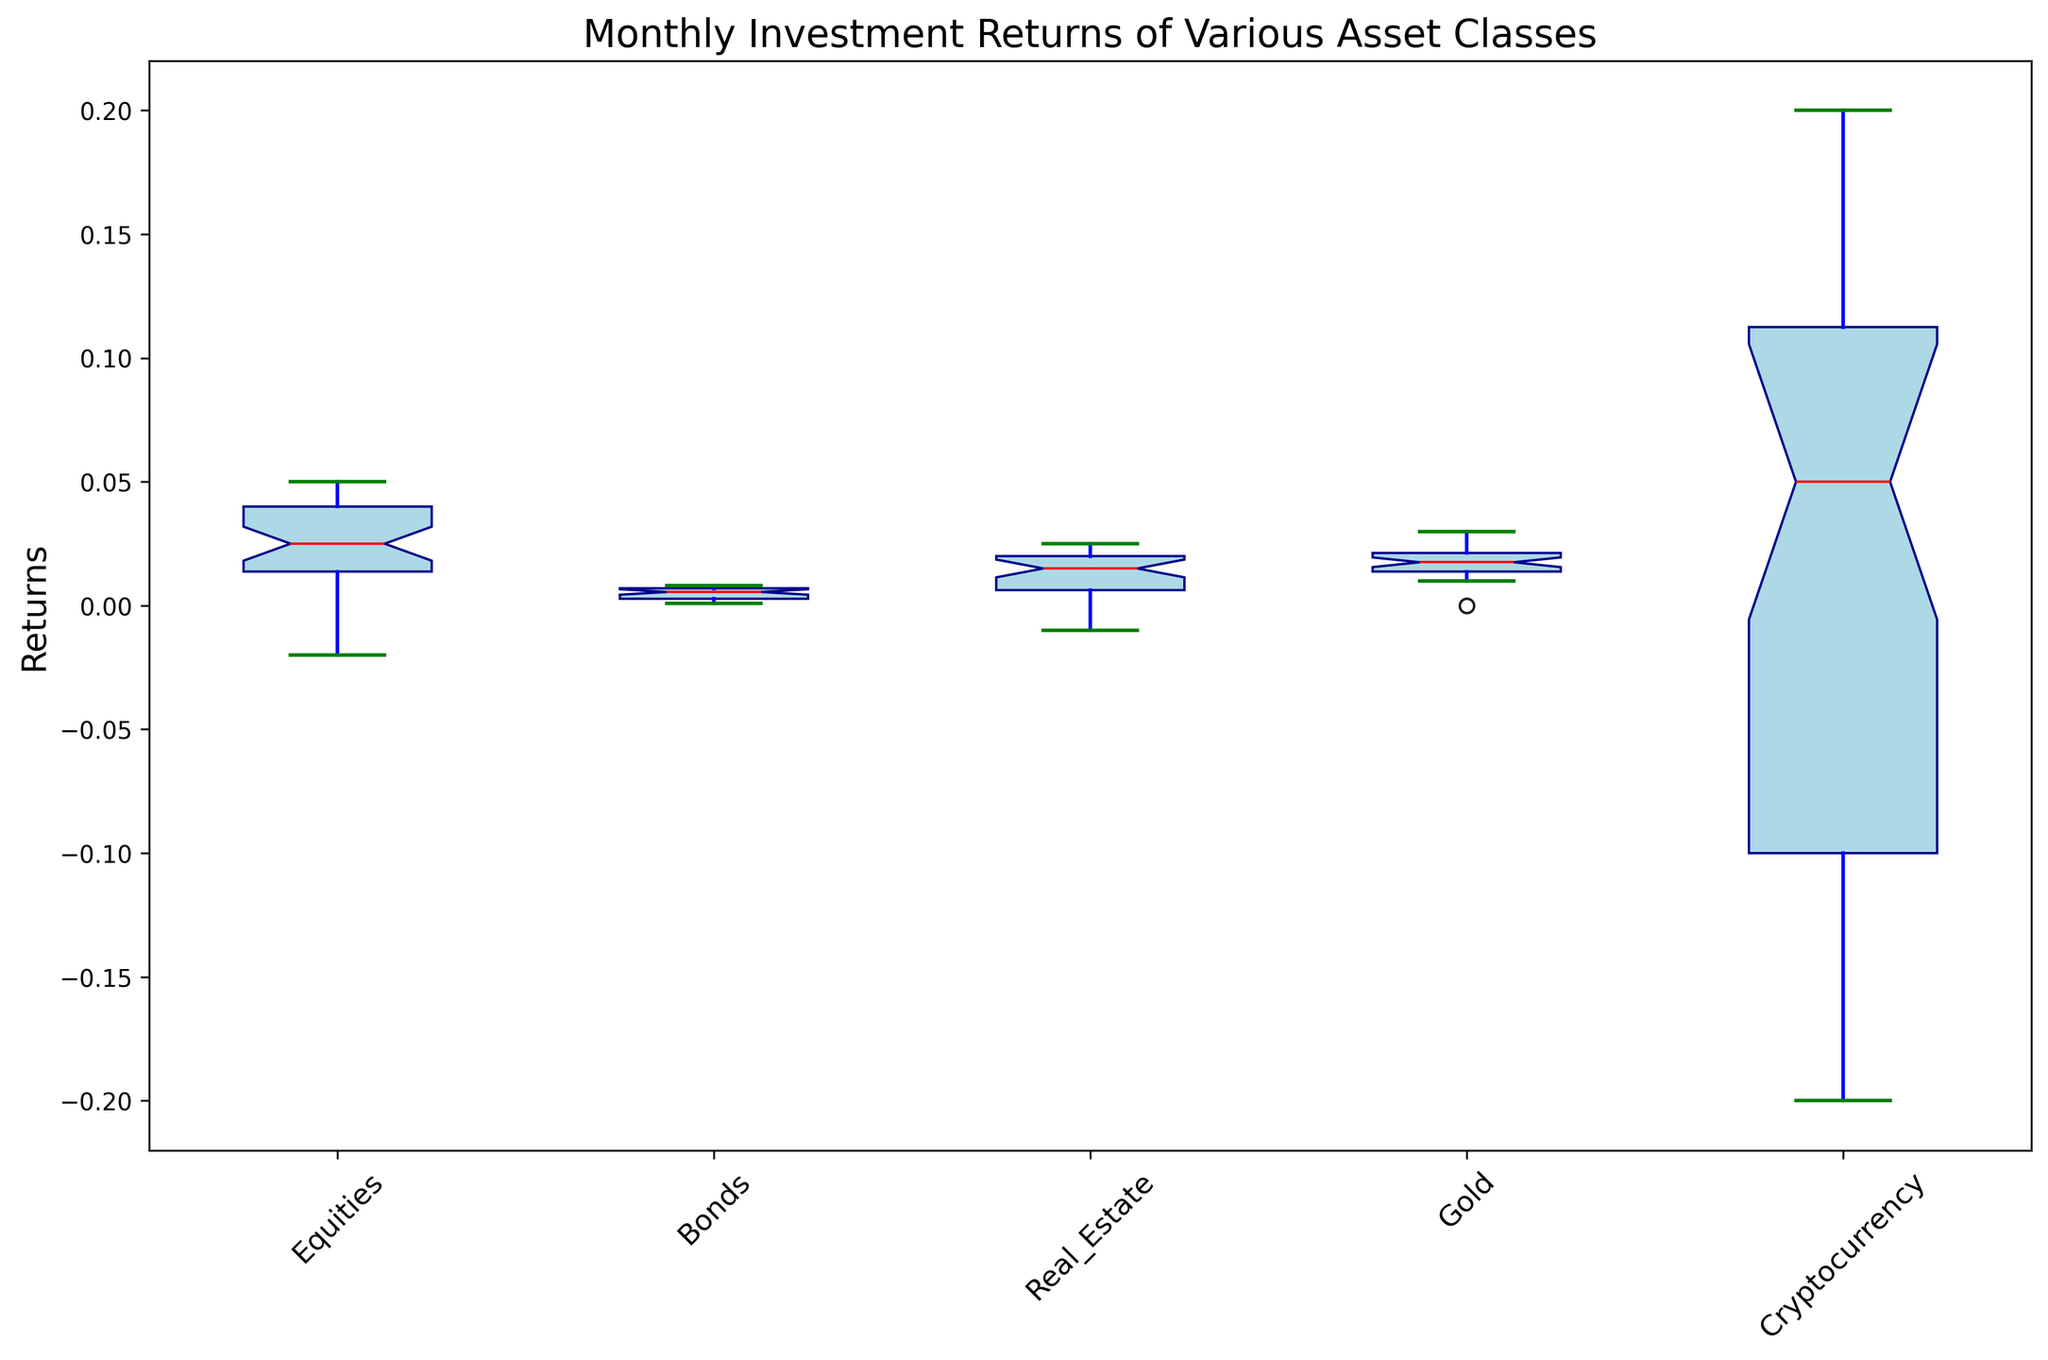What's the median return of the Equities class? To find the median return of the Equities class, look at the central value of the box for Equities. The red line within the box represents the median.
Answer: 0.03 Which asset class has the highest whisker (maximum return)? The highest value of the top whisker among the asset classes indicates the maximum outlier. The top whisker of the Cryptocurrency box extends the highest upwards.
Answer: Cryptocurrency Compare the interquartile range (IQR) of Bonds and Gold. Which is larger? The IQR is the range between the first quartile (Q1) and the third quartile (Q3). Visually, the height of the box represents the IQR. Gold has a taller box than Bonds, indicating a larger IQR.
Answer: Gold Which asset class has the lowest median return? The red line inside each box represents the median. Looking at the medians of each asset class, the lowest red line is found in Bonds.
Answer: Bonds What's the difference between the median returns of Real Estate and Equities? Check the red lines inside the boxes for both Real Estate and Equities. Subtract the median of Equities (0.03) from the median of Real Estate (0.015).
Answer: 0.015 Is there any asset class with a negative lower whisker? The lower whisker represents the minimum return. Look for any boxes where the lower whisker extends below zero. Equities, Real Estate, and Cryptocurrency all show negative lower whiskers.
Answer: Yes What's the range of returns for the Equities asset class? The range is the difference between the highest (top whisker) and lowest (bottom whisker) values. For Equities, the highest whisker is at around 0.05 and the lowest is around -0.02.
Answer: 0.07 Which asset class has the most outliers? Outliers are indicated by points outside the whiskers. By counting the red dots outside the whiskers, Cryptocurrency shows the most outliers.
Answer: Cryptocurrency Considering the interquartile ranges, which asset class appears to be the least volatile? The IQR (height of the box) represents volatility. The shorter the box, the less volatile the returns. Bonds and Real Estate both have relatively short boxes, but Bonds has a slightly shorter box.
Answer: Bonds 